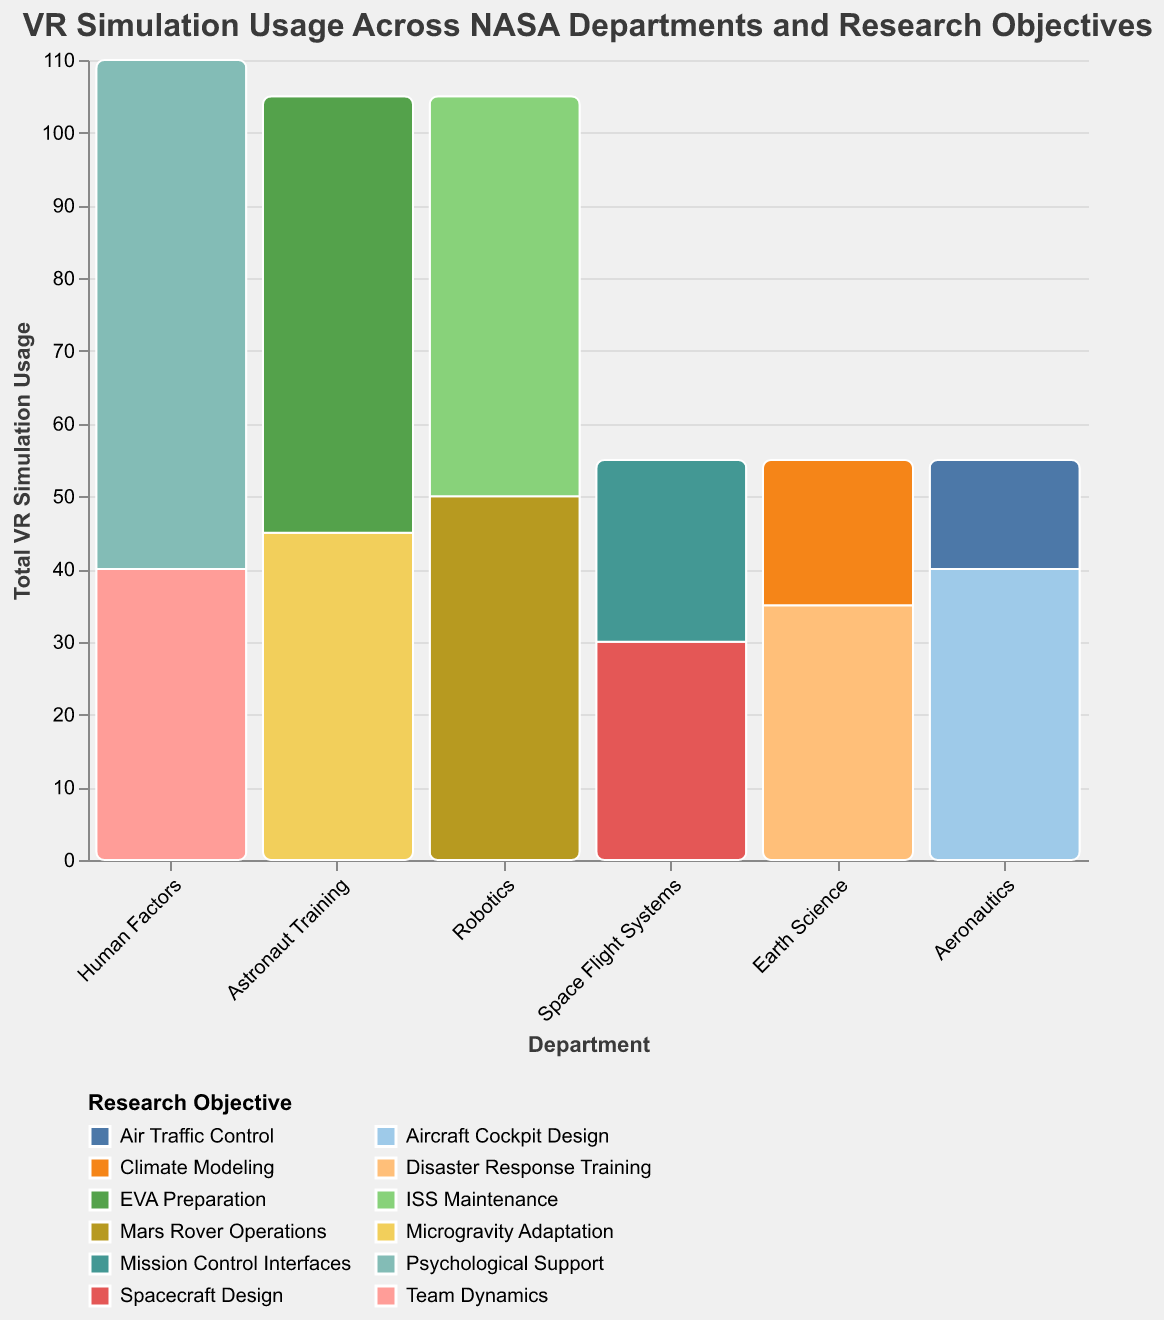What is the total VR simulation usage for the Robotics department? The total VR simulation usage for the Robotics department is calculated by summing the values for Mars Rover Operations (50) and ISS Maintenance (55), giving 50 + 55 = 105.
Answer: 105 Which department has the highest total VR simulation usage? By examining the bar heights and summing usages within each department, the Human Factors department has the highest usage with 70 for Psychological Support and 40 for Team Dynamics, totaling 110.
Answer: Human Factors Within the Aeronautics department, which research objective has the higher VR simulation usage? For Aeronautics, Aircraft Cockpit Design has a usage of 40, whereas Air Traffic Control has a usage of 15. Therefore, Aircraft Cockpit Design has the higher usage.
Answer: Aircraft Cockpit Design What is the total VR simulation usage across all NASA departments? Summing the VR simulation uses for all objectives across all departments gives 45 (Microgravity Adaptation) + 60 (EVA Preparation) + 30 (Spacecraft Design) + 25 (Mission Control Interfaces) + 20 (Climate Modeling) + 35 (Disaster Response Training) + 40 (Aircraft Cockpit Design) + 15 (Air Traffic Control) + 50 (Mars Rover Operations) + 55 (ISS Maintenance) + 70 (Psychological Support) + 40 (Team Dynamics) = 485.
Answer: 485 How does the VR simulation usage for EVA Preparation compare to that for Psychological Support? EVA Preparation is 60, while Psychological Support is 70. Comparing these values, Psychological Support has a higher VR simulation usage than EVA Preparation.
Answer: Psychological Support > EVA Preparation Which research objective within Earth Science uses VR simulations more, Climate Modeling or Disaster Response Training? For Earth Science, Climate Modeling has a usage of 20, while Disaster Response Training has a usage of 35. Disaster Response Training uses VR simulations more.
Answer: Disaster Response Training Is the total VR simulation usage for Space Flight Systems higher or lower than that for Astronaut Training? Astronaut Training totals 45 (Microgravity Adaptation) + 60 (EVA Preparation) = 105, while Space Flight Systems totals 30 (Spacecraft Design) + 25 (Mission Control Interfaces) = 55. Therefore, Astronaut Training has a higher total VR simulation usage than Space Flight Systems.
Answer: Astronaut Training > Space Flight Systems What is the average VR simulation usage per research objective within the Human Factors department? The Human Factors department has two objectives: Psychological Support (70) and Team Dynamics (40). The average is calculated as (70 + 40) / 2 = 110 / 2 = 55.
Answer: 55 Which research objective has the least VR simulation usage, and which department does it belong to? Looking at all the bars, Air Traffic Control (15) has the least VR simulation usage and it belongs to the Aeronautics department.
Answer: Air Traffic Control, Aeronautics By how much does the VR simulation usage for Mars Rover Operations exceed that for Spacecraft Design? Mars Rover Operations has a usage of 50 and Spacecraft Design has a usage of 30. The difference is 50 - 30 = 20.
Answer: 20 